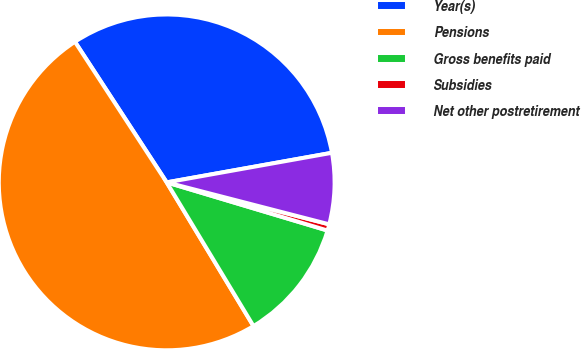Convert chart. <chart><loc_0><loc_0><loc_500><loc_500><pie_chart><fcel>Year(s)<fcel>Pensions<fcel>Gross benefits paid<fcel>Subsidies<fcel>Net other postretirement<nl><fcel>31.38%<fcel>49.44%<fcel>11.72%<fcel>0.61%<fcel>6.84%<nl></chart> 